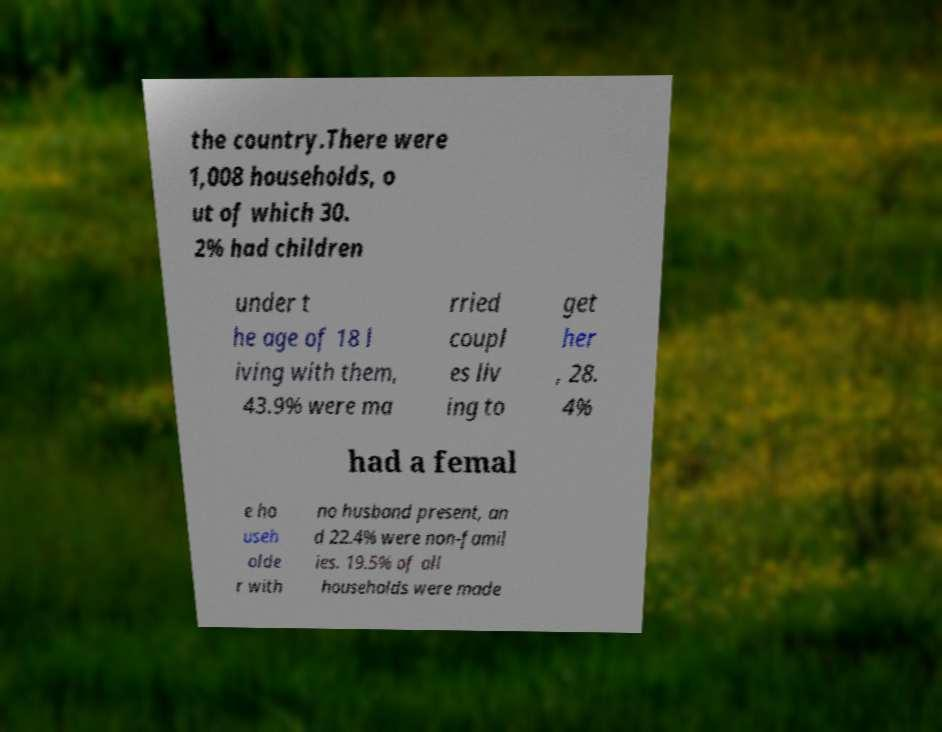There's text embedded in this image that I need extracted. Can you transcribe it verbatim? the country.There were 1,008 households, o ut of which 30. 2% had children under t he age of 18 l iving with them, 43.9% were ma rried coupl es liv ing to get her , 28. 4% had a femal e ho useh olde r with no husband present, an d 22.4% were non-famil ies. 19.5% of all households were made 